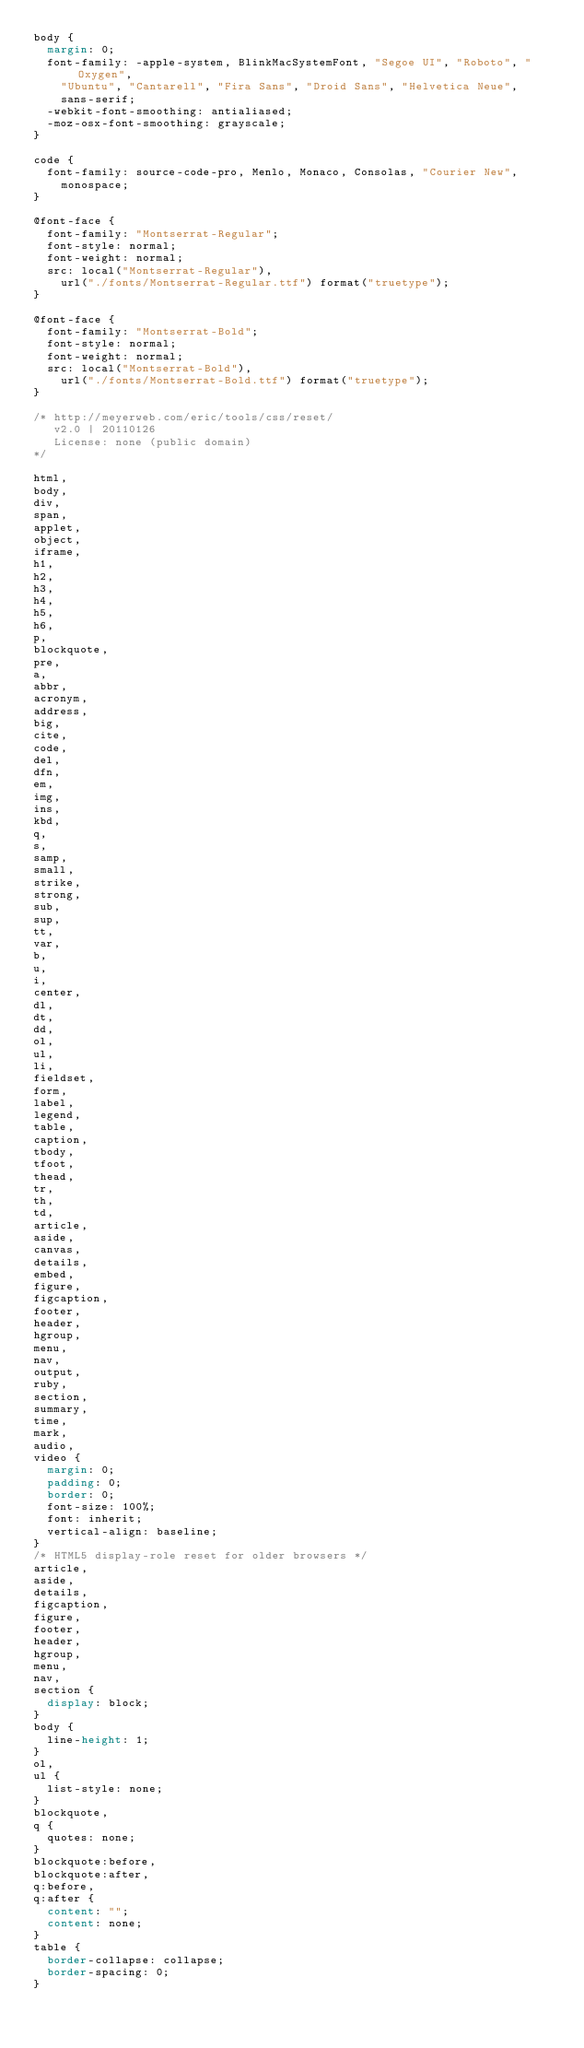Convert code to text. <code><loc_0><loc_0><loc_500><loc_500><_CSS_>body {
  margin: 0;
  font-family: -apple-system, BlinkMacSystemFont, "Segoe UI", "Roboto", "Oxygen",
    "Ubuntu", "Cantarell", "Fira Sans", "Droid Sans", "Helvetica Neue",
    sans-serif;
  -webkit-font-smoothing: antialiased;
  -moz-osx-font-smoothing: grayscale;
}

code {
  font-family: source-code-pro, Menlo, Monaco, Consolas, "Courier New",
    monospace;
}

@font-face {
  font-family: "Montserrat-Regular";
  font-style: normal;
  font-weight: normal;
  src: local("Montserrat-Regular"),
    url("./fonts/Montserrat-Regular.ttf") format("truetype");
}

@font-face {
  font-family: "Montserrat-Bold";
  font-style: normal;
  font-weight: normal;
  src: local("Montserrat-Bold"),
    url("./fonts/Montserrat-Bold.ttf") format("truetype");
}

/* http://meyerweb.com/eric/tools/css/reset/ 
   v2.0 | 20110126
   License: none (public domain)
*/

html,
body,
div,
span,
applet,
object,
iframe,
h1,
h2,
h3,
h4,
h5,
h6,
p,
blockquote,
pre,
a,
abbr,
acronym,
address,
big,
cite,
code,
del,
dfn,
em,
img,
ins,
kbd,
q,
s,
samp,
small,
strike,
strong,
sub,
sup,
tt,
var,
b,
u,
i,
center,
dl,
dt,
dd,
ol,
ul,
li,
fieldset,
form,
label,
legend,
table,
caption,
tbody,
tfoot,
thead,
tr,
th,
td,
article,
aside,
canvas,
details,
embed,
figure,
figcaption,
footer,
header,
hgroup,
menu,
nav,
output,
ruby,
section,
summary,
time,
mark,
audio,
video {
  margin: 0;
  padding: 0;
  border: 0;
  font-size: 100%;
  font: inherit;
  vertical-align: baseline;
}
/* HTML5 display-role reset for older browsers */
article,
aside,
details,
figcaption,
figure,
footer,
header,
hgroup,
menu,
nav,
section {
  display: block;
}
body {
  line-height: 1;
}
ol,
ul {
  list-style: none;
}
blockquote,
q {
  quotes: none;
}
blockquote:before,
blockquote:after,
q:before,
q:after {
  content: "";
  content: none;
}
table {
  border-collapse: collapse;
  border-spacing: 0;
}
</code> 